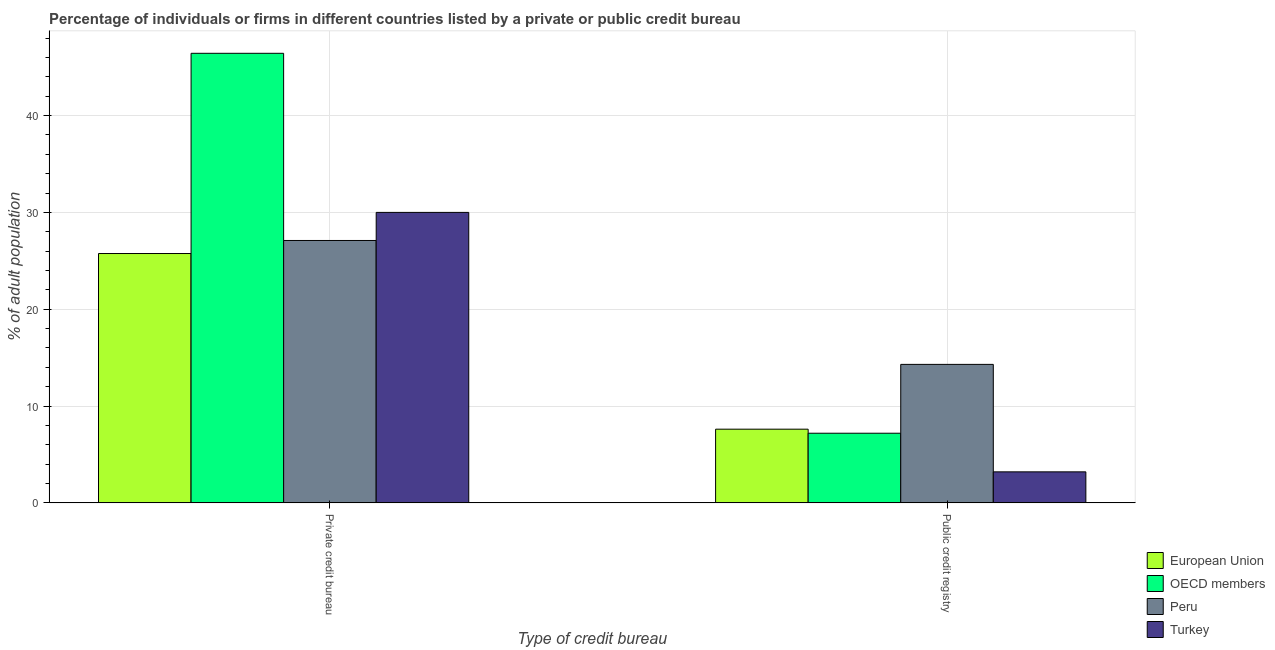How many different coloured bars are there?
Your response must be concise. 4. Are the number of bars on each tick of the X-axis equal?
Provide a succinct answer. Yes. How many bars are there on the 2nd tick from the left?
Ensure brevity in your answer.  4. How many bars are there on the 2nd tick from the right?
Provide a succinct answer. 4. What is the label of the 1st group of bars from the left?
Provide a short and direct response. Private credit bureau. What is the percentage of firms listed by public credit bureau in European Union?
Make the answer very short. 7.61. Across all countries, what is the minimum percentage of firms listed by private credit bureau?
Provide a short and direct response. 25.75. In which country was the percentage of firms listed by public credit bureau maximum?
Your response must be concise. Peru. In which country was the percentage of firms listed by public credit bureau minimum?
Your answer should be very brief. Turkey. What is the total percentage of firms listed by private credit bureau in the graph?
Your response must be concise. 129.29. What is the difference between the percentage of firms listed by private credit bureau in Peru and that in European Union?
Keep it short and to the point. 1.35. What is the difference between the percentage of firms listed by private credit bureau in European Union and the percentage of firms listed by public credit bureau in Peru?
Give a very brief answer. 11.45. What is the average percentage of firms listed by public credit bureau per country?
Your answer should be very brief. 8.07. What is the difference between the percentage of firms listed by private credit bureau and percentage of firms listed by public credit bureau in Peru?
Provide a succinct answer. 12.8. What is the ratio of the percentage of firms listed by public credit bureau in OECD members to that in Peru?
Make the answer very short. 0.5. Is the percentage of firms listed by public credit bureau in OECD members less than that in Peru?
Provide a succinct answer. Yes. In how many countries, is the percentage of firms listed by public credit bureau greater than the average percentage of firms listed by public credit bureau taken over all countries?
Ensure brevity in your answer.  1. Are all the bars in the graph horizontal?
Your response must be concise. No. Are the values on the major ticks of Y-axis written in scientific E-notation?
Keep it short and to the point. No. Does the graph contain any zero values?
Make the answer very short. No. Does the graph contain grids?
Keep it short and to the point. Yes. Where does the legend appear in the graph?
Give a very brief answer. Bottom right. How many legend labels are there?
Offer a terse response. 4. What is the title of the graph?
Your response must be concise. Percentage of individuals or firms in different countries listed by a private or public credit bureau. What is the label or title of the X-axis?
Keep it short and to the point. Type of credit bureau. What is the label or title of the Y-axis?
Your answer should be compact. % of adult population. What is the % of adult population of European Union in Private credit bureau?
Keep it short and to the point. 25.75. What is the % of adult population in OECD members in Private credit bureau?
Offer a very short reply. 46.43. What is the % of adult population of Peru in Private credit bureau?
Your answer should be very brief. 27.1. What is the % of adult population in Turkey in Private credit bureau?
Offer a very short reply. 30. What is the % of adult population of European Union in Public credit registry?
Make the answer very short. 7.61. What is the % of adult population in OECD members in Public credit registry?
Make the answer very short. 7.19. Across all Type of credit bureau, what is the maximum % of adult population in European Union?
Ensure brevity in your answer.  25.75. Across all Type of credit bureau, what is the maximum % of adult population of OECD members?
Offer a very short reply. 46.43. Across all Type of credit bureau, what is the maximum % of adult population in Peru?
Make the answer very short. 27.1. Across all Type of credit bureau, what is the maximum % of adult population of Turkey?
Provide a succinct answer. 30. Across all Type of credit bureau, what is the minimum % of adult population of European Union?
Your answer should be compact. 7.61. Across all Type of credit bureau, what is the minimum % of adult population of OECD members?
Offer a terse response. 7.19. Across all Type of credit bureau, what is the minimum % of adult population in Turkey?
Ensure brevity in your answer.  3.2. What is the total % of adult population in European Union in the graph?
Provide a short and direct response. 33.36. What is the total % of adult population in OECD members in the graph?
Keep it short and to the point. 53.62. What is the total % of adult population in Peru in the graph?
Offer a terse response. 41.4. What is the total % of adult population of Turkey in the graph?
Provide a succinct answer. 33.2. What is the difference between the % of adult population of European Union in Private credit bureau and that in Public credit registry?
Offer a terse response. 18.14. What is the difference between the % of adult population in OECD members in Private credit bureau and that in Public credit registry?
Your response must be concise. 39.24. What is the difference between the % of adult population in Turkey in Private credit bureau and that in Public credit registry?
Ensure brevity in your answer.  26.8. What is the difference between the % of adult population of European Union in Private credit bureau and the % of adult population of OECD members in Public credit registry?
Your answer should be very brief. 18.56. What is the difference between the % of adult population of European Union in Private credit bureau and the % of adult population of Peru in Public credit registry?
Keep it short and to the point. 11.45. What is the difference between the % of adult population of European Union in Private credit bureau and the % of adult population of Turkey in Public credit registry?
Your answer should be compact. 22.55. What is the difference between the % of adult population of OECD members in Private credit bureau and the % of adult population of Peru in Public credit registry?
Make the answer very short. 32.13. What is the difference between the % of adult population in OECD members in Private credit bureau and the % of adult population in Turkey in Public credit registry?
Offer a very short reply. 43.23. What is the difference between the % of adult population in Peru in Private credit bureau and the % of adult population in Turkey in Public credit registry?
Offer a very short reply. 23.9. What is the average % of adult population of European Union per Type of credit bureau?
Make the answer very short. 16.68. What is the average % of adult population of OECD members per Type of credit bureau?
Give a very brief answer. 26.81. What is the average % of adult population in Peru per Type of credit bureau?
Offer a very short reply. 20.7. What is the average % of adult population of Turkey per Type of credit bureau?
Offer a terse response. 16.6. What is the difference between the % of adult population of European Union and % of adult population of OECD members in Private credit bureau?
Provide a succinct answer. -20.68. What is the difference between the % of adult population of European Union and % of adult population of Peru in Private credit bureau?
Ensure brevity in your answer.  -1.35. What is the difference between the % of adult population of European Union and % of adult population of Turkey in Private credit bureau?
Your answer should be very brief. -4.25. What is the difference between the % of adult population of OECD members and % of adult population of Peru in Private credit bureau?
Give a very brief answer. 19.33. What is the difference between the % of adult population in OECD members and % of adult population in Turkey in Private credit bureau?
Your response must be concise. 16.43. What is the difference between the % of adult population in European Union and % of adult population in OECD members in Public credit registry?
Keep it short and to the point. 0.42. What is the difference between the % of adult population in European Union and % of adult population in Peru in Public credit registry?
Give a very brief answer. -6.69. What is the difference between the % of adult population of European Union and % of adult population of Turkey in Public credit registry?
Provide a succinct answer. 4.41. What is the difference between the % of adult population in OECD members and % of adult population in Peru in Public credit registry?
Offer a very short reply. -7.11. What is the difference between the % of adult population of OECD members and % of adult population of Turkey in Public credit registry?
Keep it short and to the point. 3.99. What is the ratio of the % of adult population of European Union in Private credit bureau to that in Public credit registry?
Give a very brief answer. 3.38. What is the ratio of the % of adult population in OECD members in Private credit bureau to that in Public credit registry?
Your answer should be compact. 6.46. What is the ratio of the % of adult population in Peru in Private credit bureau to that in Public credit registry?
Your answer should be very brief. 1.9. What is the ratio of the % of adult population of Turkey in Private credit bureau to that in Public credit registry?
Keep it short and to the point. 9.38. What is the difference between the highest and the second highest % of adult population of European Union?
Ensure brevity in your answer.  18.14. What is the difference between the highest and the second highest % of adult population in OECD members?
Make the answer very short. 39.24. What is the difference between the highest and the second highest % of adult population in Peru?
Keep it short and to the point. 12.8. What is the difference between the highest and the second highest % of adult population in Turkey?
Keep it short and to the point. 26.8. What is the difference between the highest and the lowest % of adult population of European Union?
Provide a short and direct response. 18.14. What is the difference between the highest and the lowest % of adult population of OECD members?
Ensure brevity in your answer.  39.24. What is the difference between the highest and the lowest % of adult population of Turkey?
Provide a succinct answer. 26.8. 